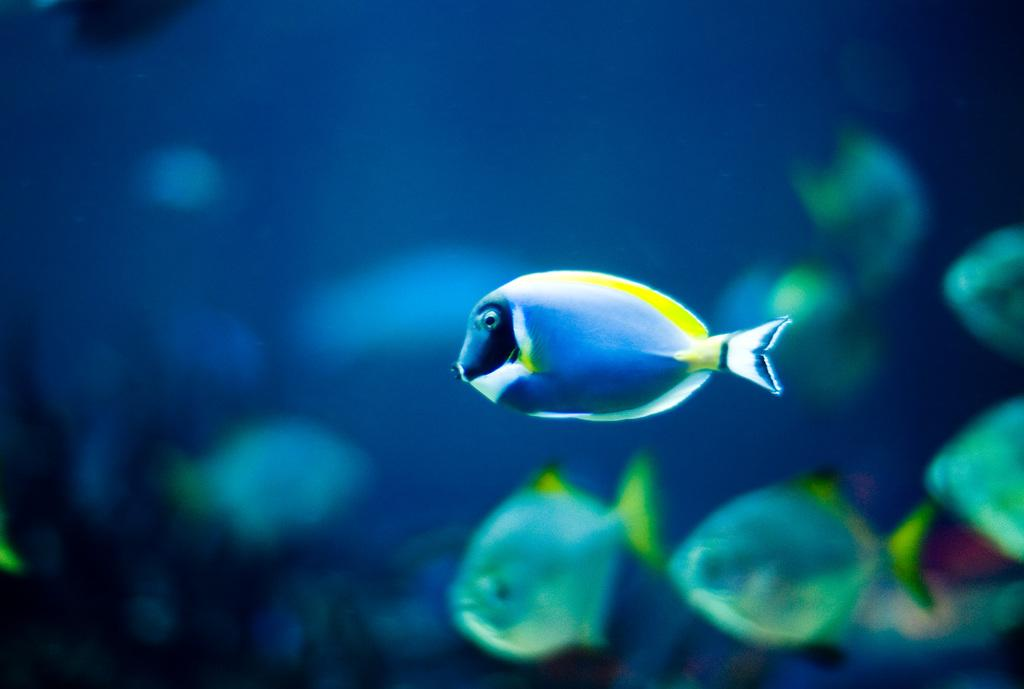What type of animals can be seen in the image? Fish can be seen in the image. Where are the fish located in the image? The fish are visible underwater in the image. Can you describe the background of the image? There are fish visible in the background of the image. What type of skin condition can be seen on the fish in the image? There is no indication of any skin condition on the fish in the image. Is there any quicksand present in the image? There is no quicksand present in the image; it features underwater fish. How many rings are visible on the fish in the image? There are no rings visible on the fish in the image. 